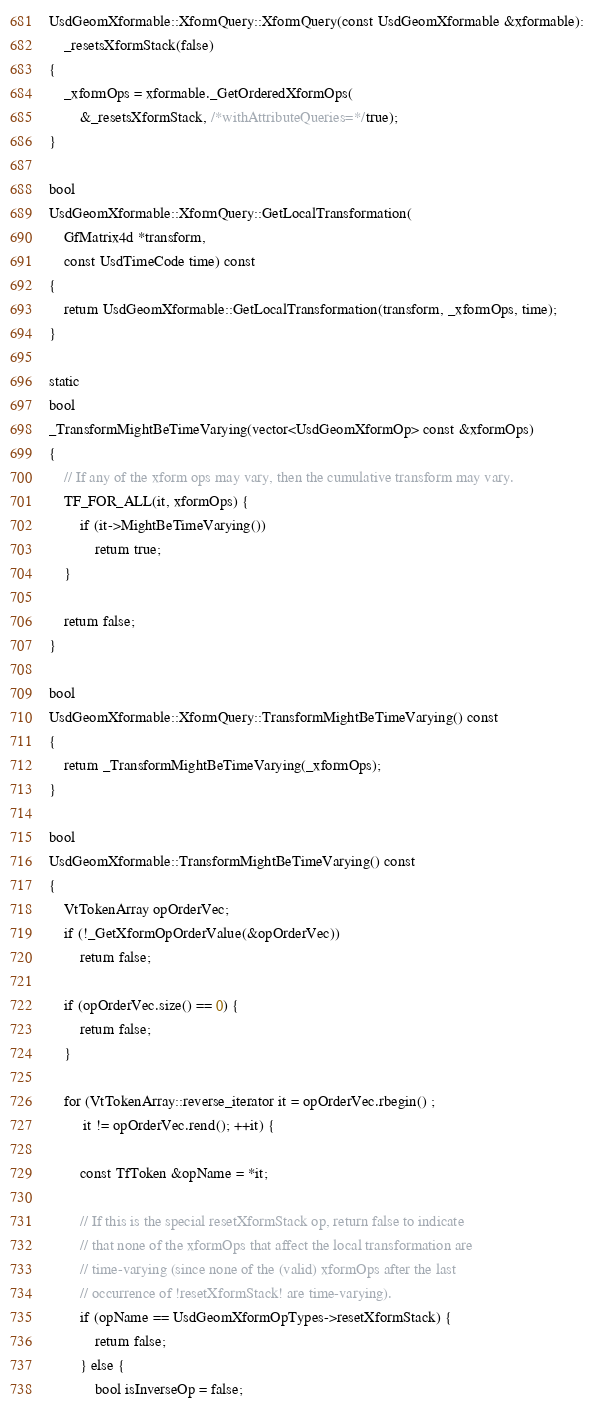<code> <loc_0><loc_0><loc_500><loc_500><_C++_>
UsdGeomXformable::XformQuery::XformQuery(const UsdGeomXformable &xformable):
    _resetsXformStack(false)
{
    _xformOps = xformable._GetOrderedXformOps(
        &_resetsXformStack, /*withAttributeQueries=*/true);
}

bool 
UsdGeomXformable::XformQuery::GetLocalTransformation(
    GfMatrix4d *transform,
    const UsdTimeCode time) const 
{
    return UsdGeomXformable::GetLocalTransformation(transform, _xformOps, time);
}

static
bool 
_TransformMightBeTimeVarying(vector<UsdGeomXformOp> const &xformOps)
{
    // If any of the xform ops may vary, then the cumulative transform may vary.
    TF_FOR_ALL(it, xformOps) {
        if (it->MightBeTimeVarying())
            return true;
    }

    return false;
}

bool
UsdGeomXformable::XformQuery::TransformMightBeTimeVarying() const
{
    return _TransformMightBeTimeVarying(_xformOps);
}

bool
UsdGeomXformable::TransformMightBeTimeVarying() const
{
    VtTokenArray opOrderVec;
    if (!_GetXformOpOrderValue(&opOrderVec))
        return false;

    if (opOrderVec.size() == 0) {
        return false;
    }

    for (VtTokenArray::reverse_iterator it = opOrderVec.rbegin() ; 
         it != opOrderVec.rend(); ++it) {

        const TfToken &opName = *it;

        // If this is the special resetXformStack op, return false to indicate 
        // that none of the xformOps that affect the local transformation are 
        // time-varying (since none of the (valid) xformOps after the last 
        // occurrence of !resetXformStack! are time-varying).
        if (opName == UsdGeomXformOpTypes->resetXformStack) { 
            return false;
        } else {
            bool isInverseOp = false;</code> 